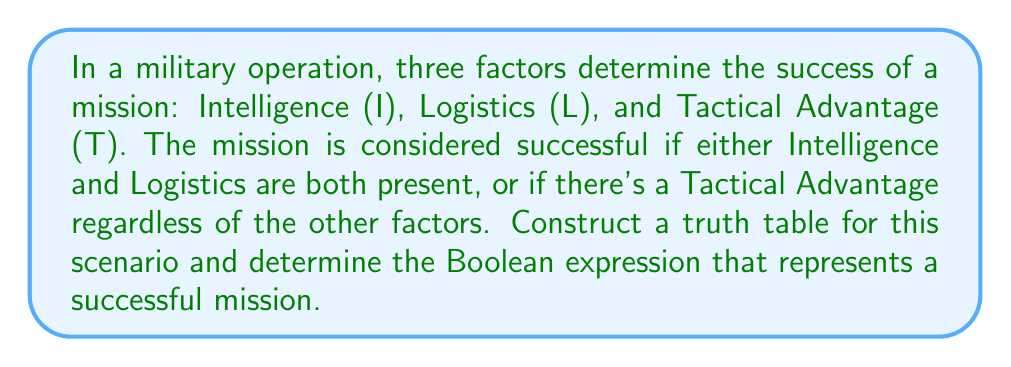Help me with this question. Let's approach this step-by-step:

1) First, we need to construct a truth table with all possible combinations of I, L, and T:

   I | L | T | Success
   0 | 0 | 0 |
   0 | 0 | 1 |
   0 | 1 | 0 |
   0 | 1 | 1 |
   1 | 0 | 0 |
   1 | 0 | 1 |
   1 | 1 | 0 |
   1 | 1 | 1 |

2) Now, let's fill in the Success column based on the given conditions:
   - Success if I and L are both present: $(I \land L)$
   - Success if there's a Tactical Advantage: $T$

   I | L | T | Success
   0 | 0 | 0 |    0
   0 | 0 | 1 |    1
   0 | 1 | 0 |    0
   0 | 1 | 1 |    1
   1 | 0 | 0 |    0
   1 | 0 | 1 |    1
   1 | 1 | 0 |    1
   1 | 1 | 1 |    1

3) From this truth table, we can derive the Boolean expression:

   $Success = (I \land L) \lor T$

4) This expression can be read as "Success occurs when (Intelligence AND Logistics) OR Tactical Advantage is present."

5) We can verify this expression by checking it against our truth table:
   - When I=1 and L=1, the mission is successful regardless of T.
   - When T=1, the mission is successful regardless of I and L.
   - In all other cases, the mission is not successful.
Answer: $(I \land L) \lor T$ 